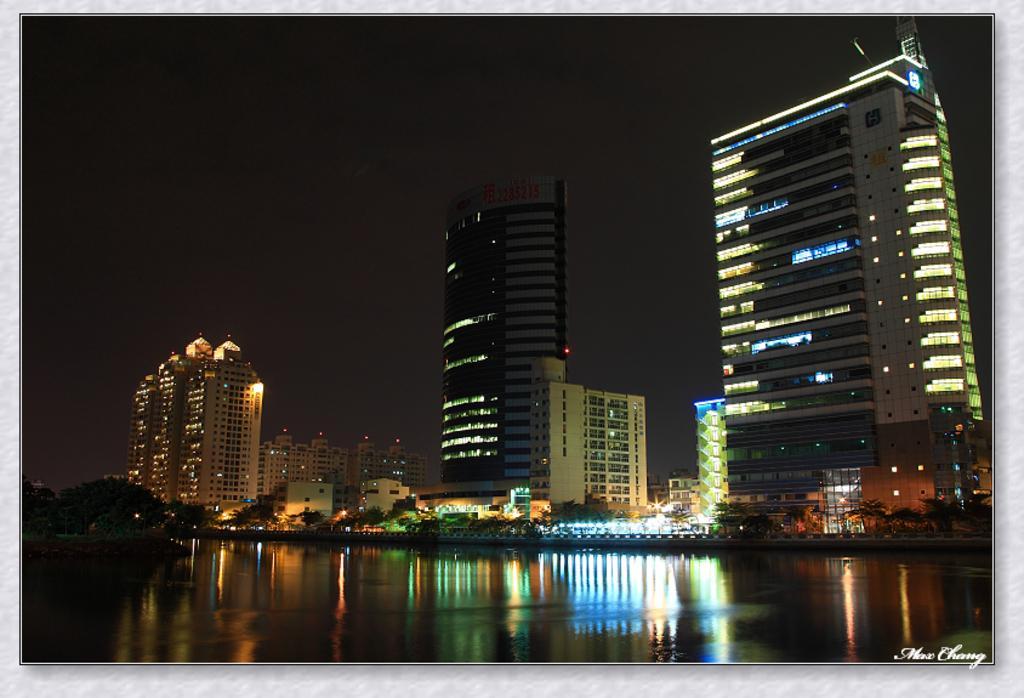In one or two sentences, can you explain what this image depicts? In the picture we can see the water surface, behind it, we can see some trees and the buildings with lights and in the background we can see the sky. 